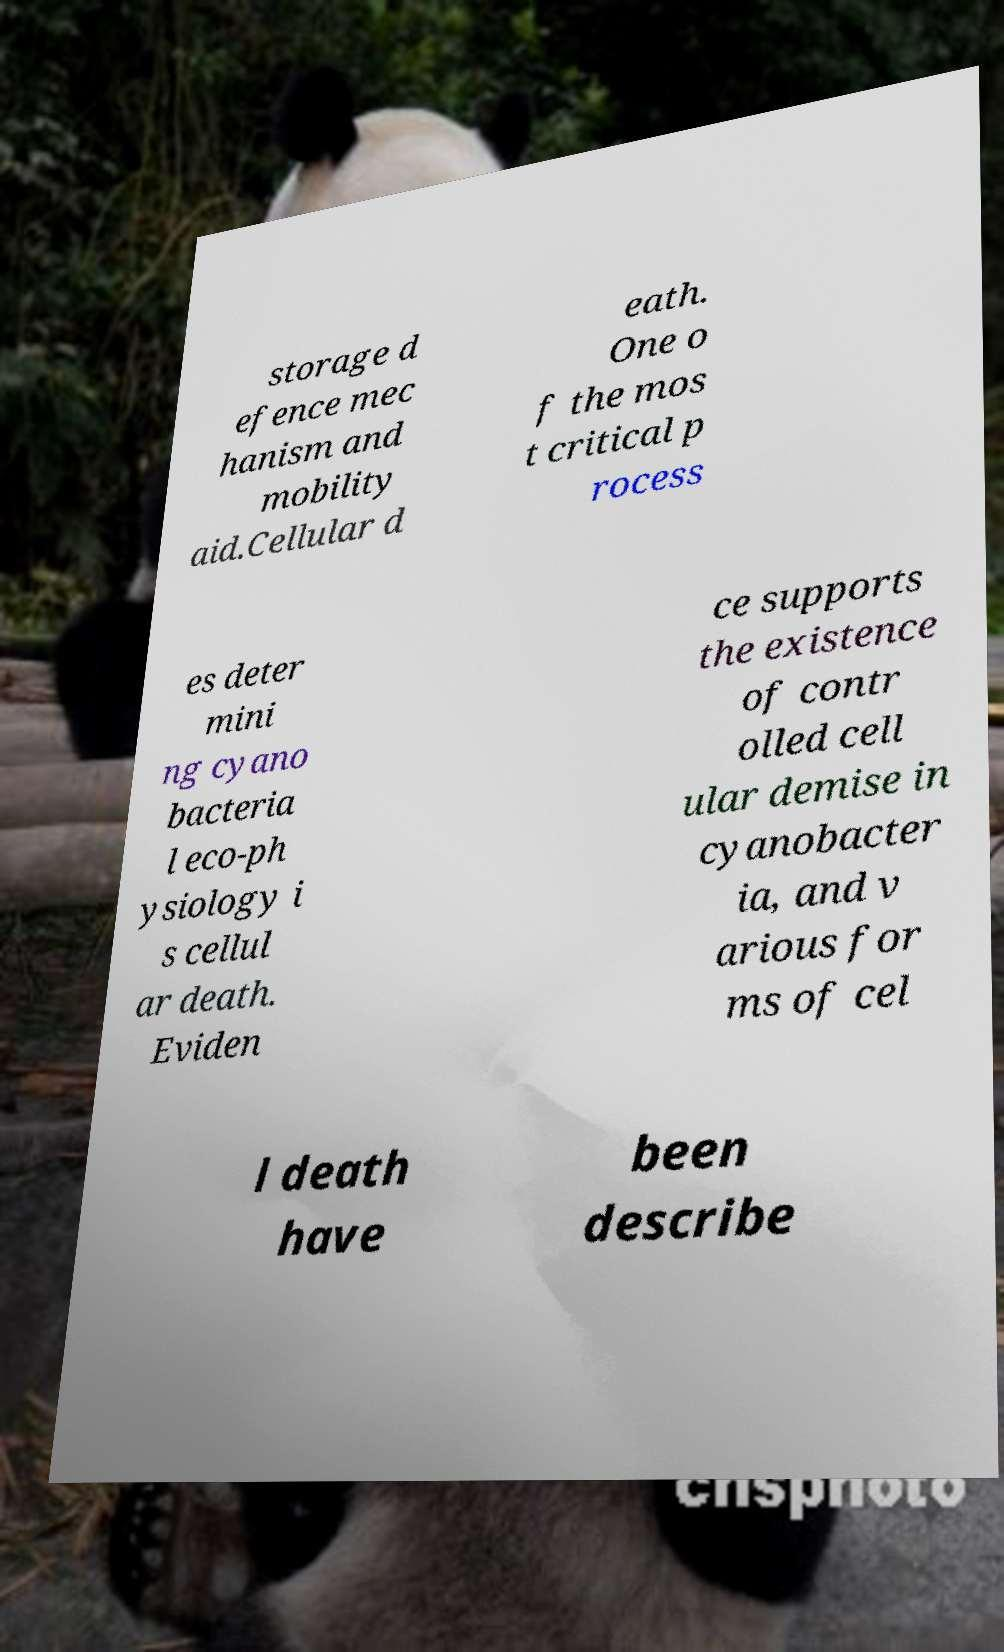Could you assist in decoding the text presented in this image and type it out clearly? storage d efence mec hanism and mobility aid.Cellular d eath. One o f the mos t critical p rocess es deter mini ng cyano bacteria l eco-ph ysiology i s cellul ar death. Eviden ce supports the existence of contr olled cell ular demise in cyanobacter ia, and v arious for ms of cel l death have been describe 